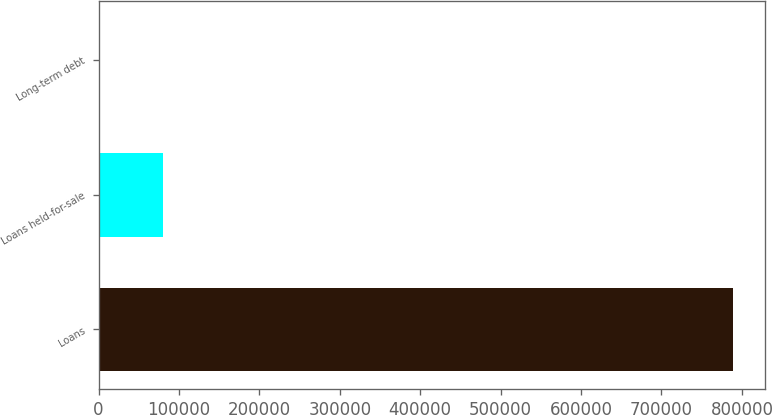Convert chart. <chart><loc_0><loc_0><loc_500><loc_500><bar_chart><fcel>Loans<fcel>Loans held-for-sale<fcel>Long-term debt<nl><fcel>789273<fcel>80718.3<fcel>1990<nl></chart> 